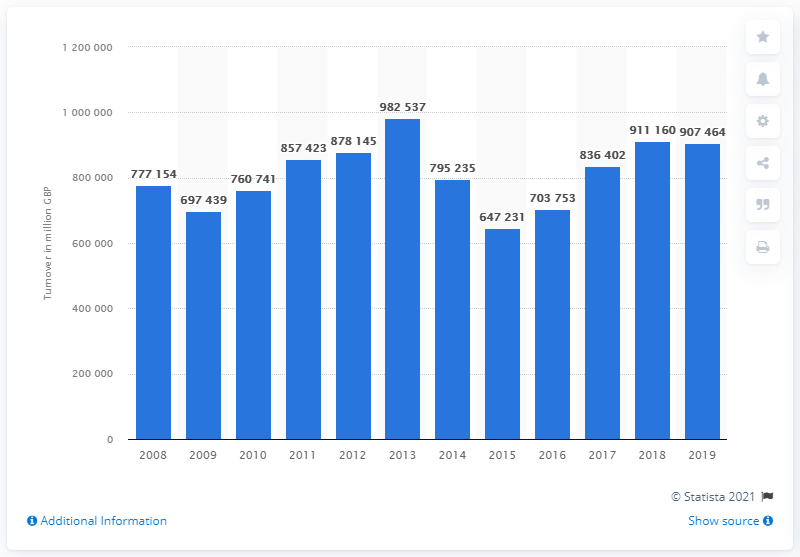List a handful of essential elements in this visual. In 2013, the turnover of wholesale trade enterprises in the UK was 982,537.. The turnover of UK wholesalers in 2019 was 907,464. In 2008, the turnover of wholesale trade enterprises in the UK was 777,154.. 